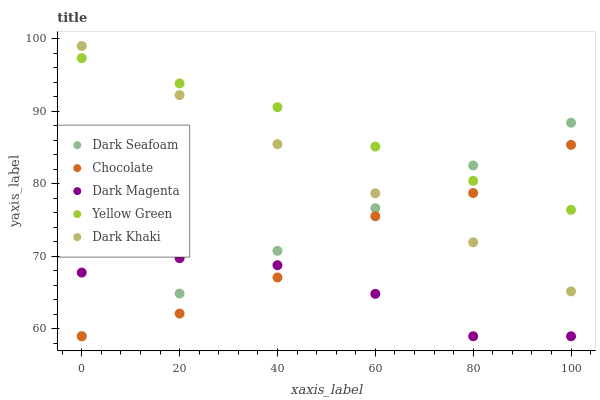Does Dark Magenta have the minimum area under the curve?
Answer yes or no. Yes. Does Yellow Green have the maximum area under the curve?
Answer yes or no. Yes. Does Dark Khaki have the minimum area under the curve?
Answer yes or no. No. Does Dark Khaki have the maximum area under the curve?
Answer yes or no. No. Is Dark Khaki the smoothest?
Answer yes or no. Yes. Is Chocolate the roughest?
Answer yes or no. Yes. Is Dark Seafoam the smoothest?
Answer yes or no. No. Is Dark Seafoam the roughest?
Answer yes or no. No. Does Dark Seafoam have the lowest value?
Answer yes or no. Yes. Does Dark Khaki have the lowest value?
Answer yes or no. No. Does Dark Khaki have the highest value?
Answer yes or no. Yes. Does Dark Seafoam have the highest value?
Answer yes or no. No. Is Dark Magenta less than Dark Khaki?
Answer yes or no. Yes. Is Dark Khaki greater than Dark Magenta?
Answer yes or no. Yes. Does Dark Magenta intersect Dark Seafoam?
Answer yes or no. Yes. Is Dark Magenta less than Dark Seafoam?
Answer yes or no. No. Is Dark Magenta greater than Dark Seafoam?
Answer yes or no. No. Does Dark Magenta intersect Dark Khaki?
Answer yes or no. No. 